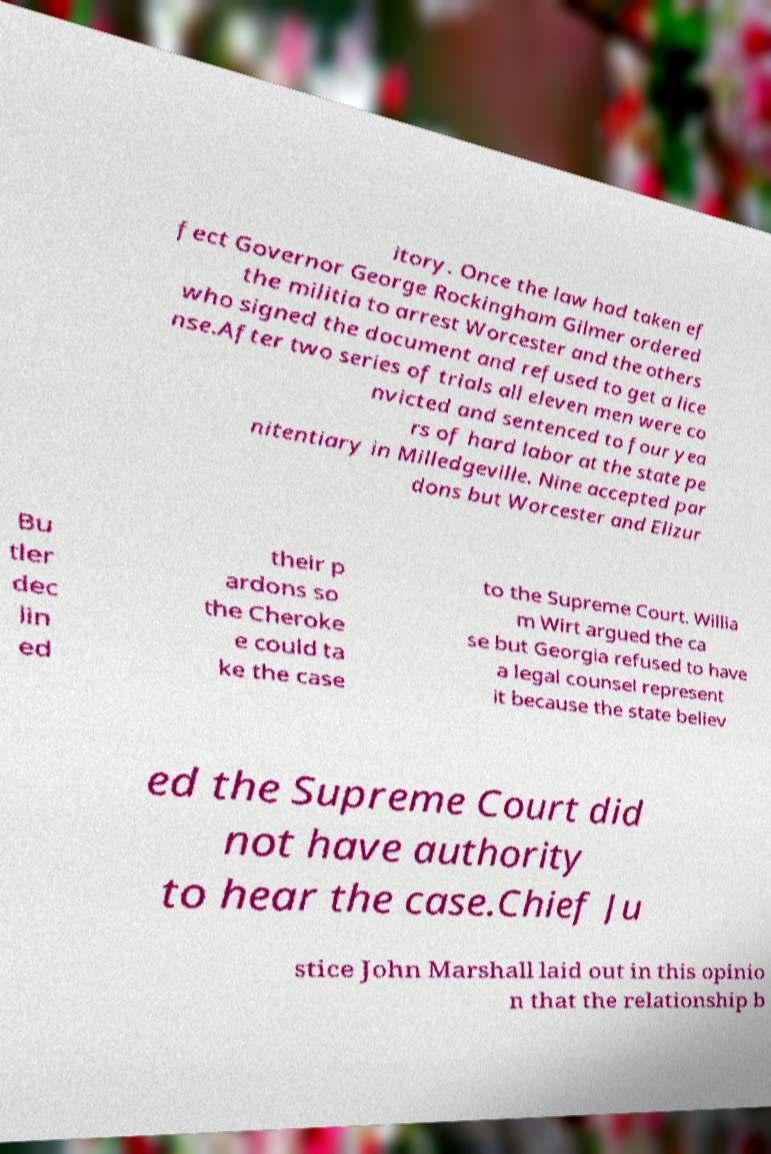Please identify and transcribe the text found in this image. itory. Once the law had taken ef fect Governor George Rockingham Gilmer ordered the militia to arrest Worcester and the others who signed the document and refused to get a lice nse.After two series of trials all eleven men were co nvicted and sentenced to four yea rs of hard labor at the state pe nitentiary in Milledgeville. Nine accepted par dons but Worcester and Elizur Bu tler dec lin ed their p ardons so the Cheroke e could ta ke the case to the Supreme Court. Willia m Wirt argued the ca se but Georgia refused to have a legal counsel represent it because the state believ ed the Supreme Court did not have authority to hear the case.Chief Ju stice John Marshall laid out in this opinio n that the relationship b 